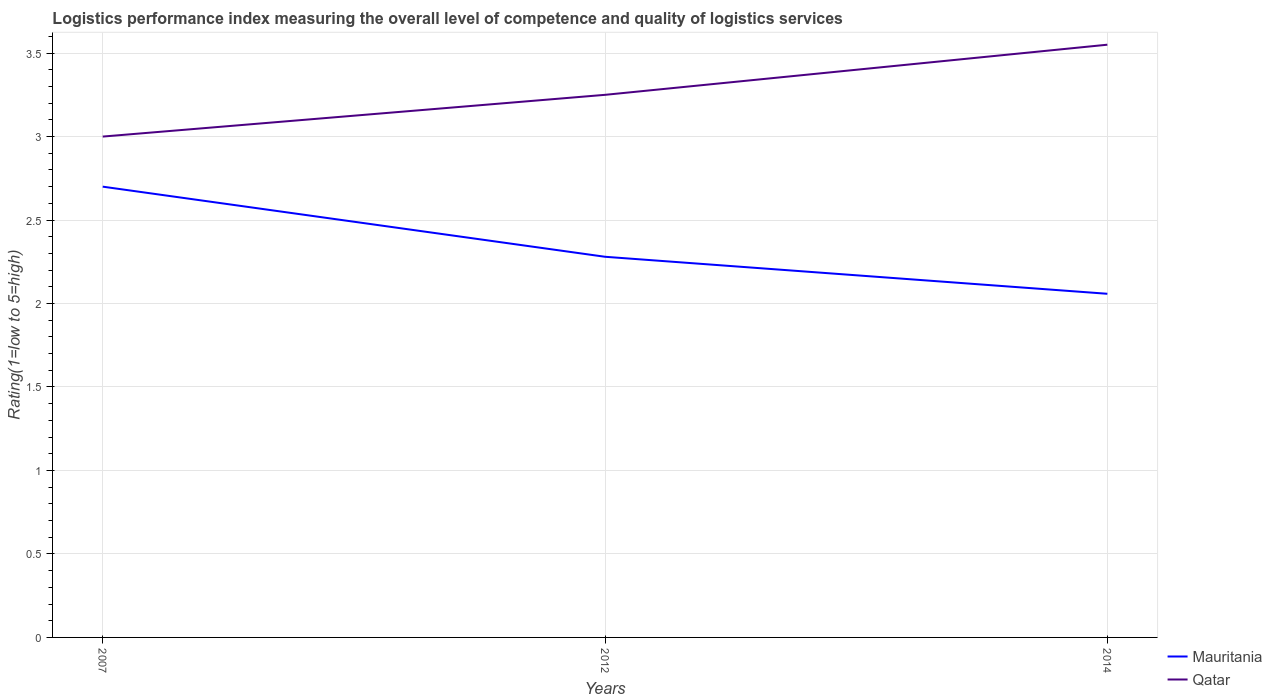How many different coloured lines are there?
Provide a short and direct response. 2. Does the line corresponding to Mauritania intersect with the line corresponding to Qatar?
Provide a succinct answer. No. What is the total Logistic performance index in Mauritania in the graph?
Give a very brief answer. 0.22. What is the difference between the highest and the second highest Logistic performance index in Qatar?
Give a very brief answer. 0.55. What is the difference between the highest and the lowest Logistic performance index in Qatar?
Provide a short and direct response. 1. Is the Logistic performance index in Qatar strictly greater than the Logistic performance index in Mauritania over the years?
Provide a short and direct response. No. How many lines are there?
Ensure brevity in your answer.  2. How many years are there in the graph?
Provide a succinct answer. 3. Are the values on the major ticks of Y-axis written in scientific E-notation?
Your response must be concise. No. Where does the legend appear in the graph?
Offer a very short reply. Bottom right. How many legend labels are there?
Offer a terse response. 2. What is the title of the graph?
Provide a short and direct response. Logistics performance index measuring the overall level of competence and quality of logistics services. What is the label or title of the Y-axis?
Provide a short and direct response. Rating(1=low to 5=high). What is the Rating(1=low to 5=high) in Qatar in 2007?
Offer a very short reply. 3. What is the Rating(1=low to 5=high) in Mauritania in 2012?
Offer a terse response. 2.28. What is the Rating(1=low to 5=high) in Qatar in 2012?
Make the answer very short. 3.25. What is the Rating(1=low to 5=high) of Mauritania in 2014?
Give a very brief answer. 2.06. What is the Rating(1=low to 5=high) of Qatar in 2014?
Keep it short and to the point. 3.55. Across all years, what is the maximum Rating(1=low to 5=high) of Mauritania?
Provide a short and direct response. 2.7. Across all years, what is the maximum Rating(1=low to 5=high) in Qatar?
Ensure brevity in your answer.  3.55. Across all years, what is the minimum Rating(1=low to 5=high) in Mauritania?
Offer a terse response. 2.06. What is the total Rating(1=low to 5=high) in Mauritania in the graph?
Provide a short and direct response. 7.04. What is the total Rating(1=low to 5=high) of Qatar in the graph?
Ensure brevity in your answer.  9.8. What is the difference between the Rating(1=low to 5=high) in Mauritania in 2007 and that in 2012?
Your response must be concise. 0.42. What is the difference between the Rating(1=low to 5=high) of Mauritania in 2007 and that in 2014?
Your response must be concise. 0.64. What is the difference between the Rating(1=low to 5=high) of Qatar in 2007 and that in 2014?
Your answer should be very brief. -0.55. What is the difference between the Rating(1=low to 5=high) in Mauritania in 2012 and that in 2014?
Offer a very short reply. 0.22. What is the difference between the Rating(1=low to 5=high) in Qatar in 2012 and that in 2014?
Offer a terse response. -0.3. What is the difference between the Rating(1=low to 5=high) of Mauritania in 2007 and the Rating(1=low to 5=high) of Qatar in 2012?
Your response must be concise. -0.55. What is the difference between the Rating(1=low to 5=high) in Mauritania in 2007 and the Rating(1=low to 5=high) in Qatar in 2014?
Keep it short and to the point. -0.85. What is the difference between the Rating(1=low to 5=high) in Mauritania in 2012 and the Rating(1=low to 5=high) in Qatar in 2014?
Your response must be concise. -1.27. What is the average Rating(1=low to 5=high) in Mauritania per year?
Your answer should be very brief. 2.35. What is the average Rating(1=low to 5=high) of Qatar per year?
Provide a succinct answer. 3.27. In the year 2012, what is the difference between the Rating(1=low to 5=high) in Mauritania and Rating(1=low to 5=high) in Qatar?
Offer a very short reply. -0.97. In the year 2014, what is the difference between the Rating(1=low to 5=high) of Mauritania and Rating(1=low to 5=high) of Qatar?
Ensure brevity in your answer.  -1.49. What is the ratio of the Rating(1=low to 5=high) of Mauritania in 2007 to that in 2012?
Your response must be concise. 1.18. What is the ratio of the Rating(1=low to 5=high) of Mauritania in 2007 to that in 2014?
Ensure brevity in your answer.  1.31. What is the ratio of the Rating(1=low to 5=high) of Qatar in 2007 to that in 2014?
Provide a succinct answer. 0.84. What is the ratio of the Rating(1=low to 5=high) of Mauritania in 2012 to that in 2014?
Your response must be concise. 1.11. What is the ratio of the Rating(1=low to 5=high) in Qatar in 2012 to that in 2014?
Your response must be concise. 0.92. What is the difference between the highest and the second highest Rating(1=low to 5=high) of Mauritania?
Ensure brevity in your answer.  0.42. What is the difference between the highest and the second highest Rating(1=low to 5=high) in Qatar?
Make the answer very short. 0.3. What is the difference between the highest and the lowest Rating(1=low to 5=high) of Mauritania?
Offer a terse response. 0.64. What is the difference between the highest and the lowest Rating(1=low to 5=high) in Qatar?
Ensure brevity in your answer.  0.55. 